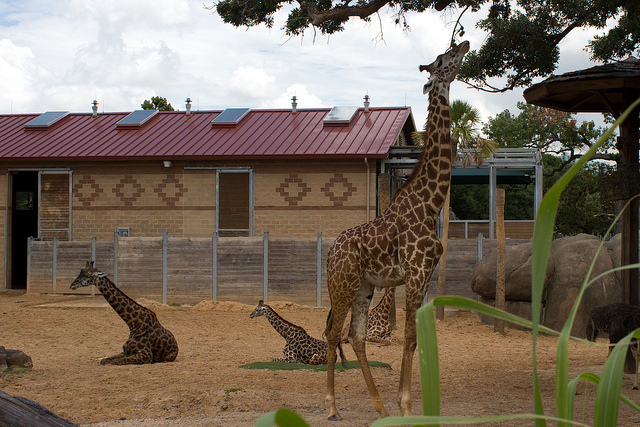<image>What time of day is it in this photo? It is ambiguous what time of the day it is in the photo. It could be morning, afternoon, or daytime. Which baby is smiling? It is ambiguous to determine which baby is smiling without the image. Which baby is smiling? I don't know which baby is smiling. It is not clear from the options given. What time of day is it in this photo? I don't know what time of day it is in the photo. However, it can be seen in the morning, afternoon or noon. 